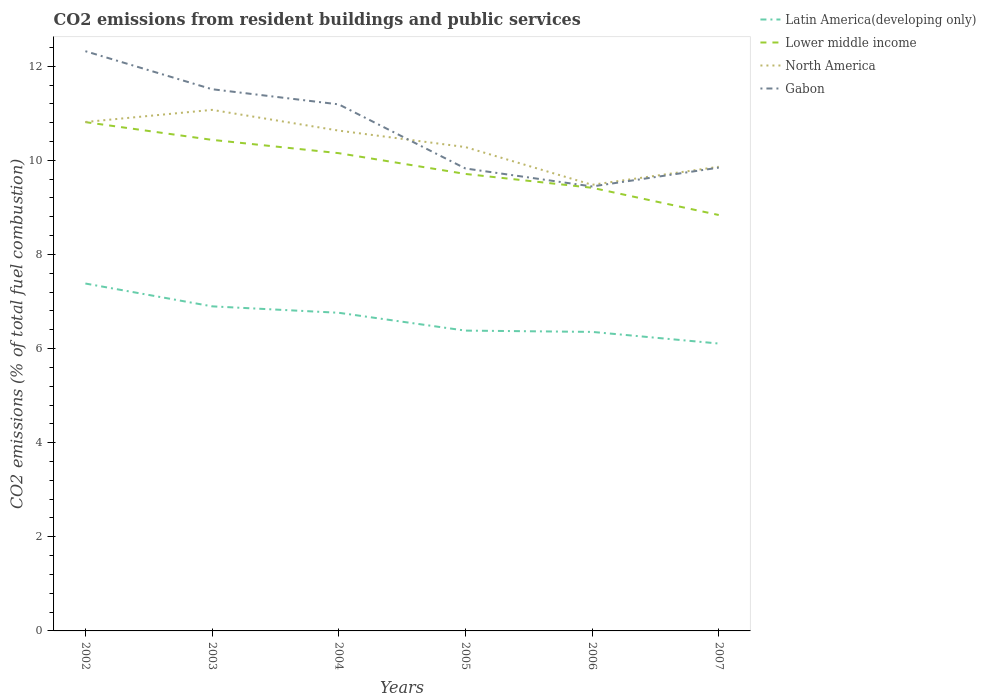How many different coloured lines are there?
Offer a very short reply. 4. Across all years, what is the maximum total CO2 emitted in Gabon?
Your response must be concise. 9.44. What is the total total CO2 emitted in North America in the graph?
Give a very brief answer. 1.21. What is the difference between the highest and the second highest total CO2 emitted in Latin America(developing only)?
Your answer should be compact. 1.28. How many lines are there?
Provide a short and direct response. 4. How many years are there in the graph?
Keep it short and to the point. 6. Does the graph contain grids?
Your answer should be compact. No. Where does the legend appear in the graph?
Ensure brevity in your answer.  Top right. What is the title of the graph?
Ensure brevity in your answer.  CO2 emissions from resident buildings and public services. What is the label or title of the Y-axis?
Provide a short and direct response. CO2 emissions (% of total fuel combustion). What is the CO2 emissions (% of total fuel combustion) in Latin America(developing only) in 2002?
Your answer should be compact. 7.38. What is the CO2 emissions (% of total fuel combustion) of Lower middle income in 2002?
Give a very brief answer. 10.81. What is the CO2 emissions (% of total fuel combustion) of North America in 2002?
Keep it short and to the point. 10.81. What is the CO2 emissions (% of total fuel combustion) of Gabon in 2002?
Your response must be concise. 12.32. What is the CO2 emissions (% of total fuel combustion) of Latin America(developing only) in 2003?
Offer a very short reply. 6.9. What is the CO2 emissions (% of total fuel combustion) in Lower middle income in 2003?
Provide a short and direct response. 10.43. What is the CO2 emissions (% of total fuel combustion) of North America in 2003?
Your answer should be compact. 11.07. What is the CO2 emissions (% of total fuel combustion) of Gabon in 2003?
Ensure brevity in your answer.  11.51. What is the CO2 emissions (% of total fuel combustion) in Latin America(developing only) in 2004?
Keep it short and to the point. 6.76. What is the CO2 emissions (% of total fuel combustion) of Lower middle income in 2004?
Your response must be concise. 10.15. What is the CO2 emissions (% of total fuel combustion) of North America in 2004?
Provide a short and direct response. 10.63. What is the CO2 emissions (% of total fuel combustion) in Gabon in 2004?
Provide a short and direct response. 11.19. What is the CO2 emissions (% of total fuel combustion) of Latin America(developing only) in 2005?
Your response must be concise. 6.38. What is the CO2 emissions (% of total fuel combustion) of Lower middle income in 2005?
Give a very brief answer. 9.71. What is the CO2 emissions (% of total fuel combustion) of North America in 2005?
Ensure brevity in your answer.  10.28. What is the CO2 emissions (% of total fuel combustion) in Gabon in 2005?
Your answer should be very brief. 9.83. What is the CO2 emissions (% of total fuel combustion) in Latin America(developing only) in 2006?
Ensure brevity in your answer.  6.35. What is the CO2 emissions (% of total fuel combustion) of Lower middle income in 2006?
Your answer should be compact. 9.42. What is the CO2 emissions (% of total fuel combustion) in North America in 2006?
Offer a very short reply. 9.48. What is the CO2 emissions (% of total fuel combustion) of Gabon in 2006?
Your answer should be compact. 9.44. What is the CO2 emissions (% of total fuel combustion) in Latin America(developing only) in 2007?
Provide a short and direct response. 6.11. What is the CO2 emissions (% of total fuel combustion) of Lower middle income in 2007?
Offer a very short reply. 8.84. What is the CO2 emissions (% of total fuel combustion) of North America in 2007?
Keep it short and to the point. 9.86. What is the CO2 emissions (% of total fuel combustion) in Gabon in 2007?
Keep it short and to the point. 9.84. Across all years, what is the maximum CO2 emissions (% of total fuel combustion) of Latin America(developing only)?
Provide a succinct answer. 7.38. Across all years, what is the maximum CO2 emissions (% of total fuel combustion) in Lower middle income?
Offer a terse response. 10.81. Across all years, what is the maximum CO2 emissions (% of total fuel combustion) of North America?
Keep it short and to the point. 11.07. Across all years, what is the maximum CO2 emissions (% of total fuel combustion) of Gabon?
Your response must be concise. 12.32. Across all years, what is the minimum CO2 emissions (% of total fuel combustion) of Latin America(developing only)?
Provide a short and direct response. 6.11. Across all years, what is the minimum CO2 emissions (% of total fuel combustion) of Lower middle income?
Provide a succinct answer. 8.84. Across all years, what is the minimum CO2 emissions (% of total fuel combustion) of North America?
Your answer should be very brief. 9.48. Across all years, what is the minimum CO2 emissions (% of total fuel combustion) in Gabon?
Offer a very short reply. 9.44. What is the total CO2 emissions (% of total fuel combustion) in Latin America(developing only) in the graph?
Offer a very short reply. 39.88. What is the total CO2 emissions (% of total fuel combustion) in Lower middle income in the graph?
Your answer should be compact. 59.36. What is the total CO2 emissions (% of total fuel combustion) in North America in the graph?
Keep it short and to the point. 62.14. What is the total CO2 emissions (% of total fuel combustion) of Gabon in the graph?
Offer a terse response. 64.13. What is the difference between the CO2 emissions (% of total fuel combustion) in Latin America(developing only) in 2002 and that in 2003?
Keep it short and to the point. 0.48. What is the difference between the CO2 emissions (% of total fuel combustion) in Lower middle income in 2002 and that in 2003?
Give a very brief answer. 0.38. What is the difference between the CO2 emissions (% of total fuel combustion) in North America in 2002 and that in 2003?
Ensure brevity in your answer.  -0.26. What is the difference between the CO2 emissions (% of total fuel combustion) in Gabon in 2002 and that in 2003?
Your answer should be very brief. 0.81. What is the difference between the CO2 emissions (% of total fuel combustion) of Latin America(developing only) in 2002 and that in 2004?
Make the answer very short. 0.62. What is the difference between the CO2 emissions (% of total fuel combustion) of Lower middle income in 2002 and that in 2004?
Your answer should be very brief. 0.66. What is the difference between the CO2 emissions (% of total fuel combustion) in North America in 2002 and that in 2004?
Make the answer very short. 0.18. What is the difference between the CO2 emissions (% of total fuel combustion) of Gabon in 2002 and that in 2004?
Your answer should be very brief. 1.13. What is the difference between the CO2 emissions (% of total fuel combustion) of Latin America(developing only) in 2002 and that in 2005?
Your answer should be compact. 1. What is the difference between the CO2 emissions (% of total fuel combustion) in Lower middle income in 2002 and that in 2005?
Ensure brevity in your answer.  1.1. What is the difference between the CO2 emissions (% of total fuel combustion) of North America in 2002 and that in 2005?
Offer a very short reply. 0.53. What is the difference between the CO2 emissions (% of total fuel combustion) in Gabon in 2002 and that in 2005?
Offer a very short reply. 2.49. What is the difference between the CO2 emissions (% of total fuel combustion) of Latin America(developing only) in 2002 and that in 2006?
Your answer should be very brief. 1.03. What is the difference between the CO2 emissions (% of total fuel combustion) of Lower middle income in 2002 and that in 2006?
Offer a very short reply. 1.4. What is the difference between the CO2 emissions (% of total fuel combustion) of North America in 2002 and that in 2006?
Ensure brevity in your answer.  1.33. What is the difference between the CO2 emissions (% of total fuel combustion) in Gabon in 2002 and that in 2006?
Offer a very short reply. 2.87. What is the difference between the CO2 emissions (% of total fuel combustion) in Latin America(developing only) in 2002 and that in 2007?
Offer a very short reply. 1.28. What is the difference between the CO2 emissions (% of total fuel combustion) in Lower middle income in 2002 and that in 2007?
Your answer should be very brief. 1.97. What is the difference between the CO2 emissions (% of total fuel combustion) in North America in 2002 and that in 2007?
Offer a terse response. 0.95. What is the difference between the CO2 emissions (% of total fuel combustion) in Gabon in 2002 and that in 2007?
Your answer should be compact. 2.47. What is the difference between the CO2 emissions (% of total fuel combustion) of Latin America(developing only) in 2003 and that in 2004?
Offer a terse response. 0.14. What is the difference between the CO2 emissions (% of total fuel combustion) of Lower middle income in 2003 and that in 2004?
Provide a short and direct response. 0.28. What is the difference between the CO2 emissions (% of total fuel combustion) in North America in 2003 and that in 2004?
Give a very brief answer. 0.44. What is the difference between the CO2 emissions (% of total fuel combustion) in Gabon in 2003 and that in 2004?
Make the answer very short. 0.32. What is the difference between the CO2 emissions (% of total fuel combustion) in Latin America(developing only) in 2003 and that in 2005?
Your response must be concise. 0.52. What is the difference between the CO2 emissions (% of total fuel combustion) in Lower middle income in 2003 and that in 2005?
Offer a terse response. 0.72. What is the difference between the CO2 emissions (% of total fuel combustion) in North America in 2003 and that in 2005?
Keep it short and to the point. 0.79. What is the difference between the CO2 emissions (% of total fuel combustion) in Gabon in 2003 and that in 2005?
Keep it short and to the point. 1.68. What is the difference between the CO2 emissions (% of total fuel combustion) of Latin America(developing only) in 2003 and that in 2006?
Provide a short and direct response. 0.54. What is the difference between the CO2 emissions (% of total fuel combustion) of Lower middle income in 2003 and that in 2006?
Keep it short and to the point. 1.02. What is the difference between the CO2 emissions (% of total fuel combustion) in North America in 2003 and that in 2006?
Ensure brevity in your answer.  1.59. What is the difference between the CO2 emissions (% of total fuel combustion) of Gabon in 2003 and that in 2006?
Ensure brevity in your answer.  2.07. What is the difference between the CO2 emissions (% of total fuel combustion) of Latin America(developing only) in 2003 and that in 2007?
Your answer should be compact. 0.79. What is the difference between the CO2 emissions (% of total fuel combustion) of Lower middle income in 2003 and that in 2007?
Keep it short and to the point. 1.6. What is the difference between the CO2 emissions (% of total fuel combustion) in North America in 2003 and that in 2007?
Keep it short and to the point. 1.21. What is the difference between the CO2 emissions (% of total fuel combustion) in Gabon in 2003 and that in 2007?
Your response must be concise. 1.67. What is the difference between the CO2 emissions (% of total fuel combustion) of Latin America(developing only) in 2004 and that in 2005?
Provide a succinct answer. 0.38. What is the difference between the CO2 emissions (% of total fuel combustion) of Lower middle income in 2004 and that in 2005?
Provide a succinct answer. 0.44. What is the difference between the CO2 emissions (% of total fuel combustion) of North America in 2004 and that in 2005?
Your response must be concise. 0.35. What is the difference between the CO2 emissions (% of total fuel combustion) of Gabon in 2004 and that in 2005?
Keep it short and to the point. 1.36. What is the difference between the CO2 emissions (% of total fuel combustion) in Latin America(developing only) in 2004 and that in 2006?
Your response must be concise. 0.41. What is the difference between the CO2 emissions (% of total fuel combustion) in Lower middle income in 2004 and that in 2006?
Your response must be concise. 0.74. What is the difference between the CO2 emissions (% of total fuel combustion) of North America in 2004 and that in 2006?
Give a very brief answer. 1.15. What is the difference between the CO2 emissions (% of total fuel combustion) of Gabon in 2004 and that in 2006?
Provide a succinct answer. 1.74. What is the difference between the CO2 emissions (% of total fuel combustion) of Latin America(developing only) in 2004 and that in 2007?
Provide a succinct answer. 0.65. What is the difference between the CO2 emissions (% of total fuel combustion) in Lower middle income in 2004 and that in 2007?
Make the answer very short. 1.31. What is the difference between the CO2 emissions (% of total fuel combustion) in North America in 2004 and that in 2007?
Your answer should be very brief. 0.77. What is the difference between the CO2 emissions (% of total fuel combustion) in Gabon in 2004 and that in 2007?
Your answer should be compact. 1.34. What is the difference between the CO2 emissions (% of total fuel combustion) of Latin America(developing only) in 2005 and that in 2006?
Make the answer very short. 0.03. What is the difference between the CO2 emissions (% of total fuel combustion) in Lower middle income in 2005 and that in 2006?
Keep it short and to the point. 0.29. What is the difference between the CO2 emissions (% of total fuel combustion) of North America in 2005 and that in 2006?
Your answer should be compact. 0.8. What is the difference between the CO2 emissions (% of total fuel combustion) in Gabon in 2005 and that in 2006?
Offer a very short reply. 0.38. What is the difference between the CO2 emissions (% of total fuel combustion) in Latin America(developing only) in 2005 and that in 2007?
Offer a terse response. 0.27. What is the difference between the CO2 emissions (% of total fuel combustion) of Lower middle income in 2005 and that in 2007?
Keep it short and to the point. 0.87. What is the difference between the CO2 emissions (% of total fuel combustion) in North America in 2005 and that in 2007?
Your answer should be compact. 0.42. What is the difference between the CO2 emissions (% of total fuel combustion) in Gabon in 2005 and that in 2007?
Provide a succinct answer. -0.02. What is the difference between the CO2 emissions (% of total fuel combustion) in Latin America(developing only) in 2006 and that in 2007?
Offer a very short reply. 0.25. What is the difference between the CO2 emissions (% of total fuel combustion) of Lower middle income in 2006 and that in 2007?
Ensure brevity in your answer.  0.58. What is the difference between the CO2 emissions (% of total fuel combustion) of North America in 2006 and that in 2007?
Give a very brief answer. -0.38. What is the difference between the CO2 emissions (% of total fuel combustion) in Gabon in 2006 and that in 2007?
Your response must be concise. -0.4. What is the difference between the CO2 emissions (% of total fuel combustion) of Latin America(developing only) in 2002 and the CO2 emissions (% of total fuel combustion) of Lower middle income in 2003?
Make the answer very short. -3.05. What is the difference between the CO2 emissions (% of total fuel combustion) in Latin America(developing only) in 2002 and the CO2 emissions (% of total fuel combustion) in North America in 2003?
Ensure brevity in your answer.  -3.69. What is the difference between the CO2 emissions (% of total fuel combustion) in Latin America(developing only) in 2002 and the CO2 emissions (% of total fuel combustion) in Gabon in 2003?
Your answer should be very brief. -4.13. What is the difference between the CO2 emissions (% of total fuel combustion) in Lower middle income in 2002 and the CO2 emissions (% of total fuel combustion) in North America in 2003?
Make the answer very short. -0.26. What is the difference between the CO2 emissions (% of total fuel combustion) in Lower middle income in 2002 and the CO2 emissions (% of total fuel combustion) in Gabon in 2003?
Give a very brief answer. -0.7. What is the difference between the CO2 emissions (% of total fuel combustion) of North America in 2002 and the CO2 emissions (% of total fuel combustion) of Gabon in 2003?
Your answer should be compact. -0.7. What is the difference between the CO2 emissions (% of total fuel combustion) of Latin America(developing only) in 2002 and the CO2 emissions (% of total fuel combustion) of Lower middle income in 2004?
Ensure brevity in your answer.  -2.77. What is the difference between the CO2 emissions (% of total fuel combustion) of Latin America(developing only) in 2002 and the CO2 emissions (% of total fuel combustion) of North America in 2004?
Ensure brevity in your answer.  -3.25. What is the difference between the CO2 emissions (% of total fuel combustion) of Latin America(developing only) in 2002 and the CO2 emissions (% of total fuel combustion) of Gabon in 2004?
Provide a succinct answer. -3.81. What is the difference between the CO2 emissions (% of total fuel combustion) in Lower middle income in 2002 and the CO2 emissions (% of total fuel combustion) in North America in 2004?
Ensure brevity in your answer.  0.18. What is the difference between the CO2 emissions (% of total fuel combustion) in Lower middle income in 2002 and the CO2 emissions (% of total fuel combustion) in Gabon in 2004?
Ensure brevity in your answer.  -0.38. What is the difference between the CO2 emissions (% of total fuel combustion) of North America in 2002 and the CO2 emissions (% of total fuel combustion) of Gabon in 2004?
Provide a succinct answer. -0.37. What is the difference between the CO2 emissions (% of total fuel combustion) of Latin America(developing only) in 2002 and the CO2 emissions (% of total fuel combustion) of Lower middle income in 2005?
Your answer should be very brief. -2.33. What is the difference between the CO2 emissions (% of total fuel combustion) of Latin America(developing only) in 2002 and the CO2 emissions (% of total fuel combustion) of North America in 2005?
Keep it short and to the point. -2.9. What is the difference between the CO2 emissions (% of total fuel combustion) in Latin America(developing only) in 2002 and the CO2 emissions (% of total fuel combustion) in Gabon in 2005?
Give a very brief answer. -2.44. What is the difference between the CO2 emissions (% of total fuel combustion) of Lower middle income in 2002 and the CO2 emissions (% of total fuel combustion) of North America in 2005?
Your answer should be very brief. 0.53. What is the difference between the CO2 emissions (% of total fuel combustion) in Lower middle income in 2002 and the CO2 emissions (% of total fuel combustion) in Gabon in 2005?
Give a very brief answer. 0.99. What is the difference between the CO2 emissions (% of total fuel combustion) in Latin America(developing only) in 2002 and the CO2 emissions (% of total fuel combustion) in Lower middle income in 2006?
Provide a short and direct response. -2.03. What is the difference between the CO2 emissions (% of total fuel combustion) of Latin America(developing only) in 2002 and the CO2 emissions (% of total fuel combustion) of North America in 2006?
Ensure brevity in your answer.  -2.1. What is the difference between the CO2 emissions (% of total fuel combustion) in Latin America(developing only) in 2002 and the CO2 emissions (% of total fuel combustion) in Gabon in 2006?
Keep it short and to the point. -2.06. What is the difference between the CO2 emissions (% of total fuel combustion) of Lower middle income in 2002 and the CO2 emissions (% of total fuel combustion) of North America in 2006?
Your answer should be compact. 1.33. What is the difference between the CO2 emissions (% of total fuel combustion) of Lower middle income in 2002 and the CO2 emissions (% of total fuel combustion) of Gabon in 2006?
Offer a terse response. 1.37. What is the difference between the CO2 emissions (% of total fuel combustion) in North America in 2002 and the CO2 emissions (% of total fuel combustion) in Gabon in 2006?
Your answer should be compact. 1.37. What is the difference between the CO2 emissions (% of total fuel combustion) in Latin America(developing only) in 2002 and the CO2 emissions (% of total fuel combustion) in Lower middle income in 2007?
Your answer should be very brief. -1.46. What is the difference between the CO2 emissions (% of total fuel combustion) of Latin America(developing only) in 2002 and the CO2 emissions (% of total fuel combustion) of North America in 2007?
Your answer should be very brief. -2.48. What is the difference between the CO2 emissions (% of total fuel combustion) in Latin America(developing only) in 2002 and the CO2 emissions (% of total fuel combustion) in Gabon in 2007?
Keep it short and to the point. -2.46. What is the difference between the CO2 emissions (% of total fuel combustion) of Lower middle income in 2002 and the CO2 emissions (% of total fuel combustion) of North America in 2007?
Make the answer very short. 0.95. What is the difference between the CO2 emissions (% of total fuel combustion) in Lower middle income in 2002 and the CO2 emissions (% of total fuel combustion) in Gabon in 2007?
Your response must be concise. 0.97. What is the difference between the CO2 emissions (% of total fuel combustion) of North America in 2002 and the CO2 emissions (% of total fuel combustion) of Gabon in 2007?
Offer a very short reply. 0.97. What is the difference between the CO2 emissions (% of total fuel combustion) of Latin America(developing only) in 2003 and the CO2 emissions (% of total fuel combustion) of Lower middle income in 2004?
Your answer should be very brief. -3.25. What is the difference between the CO2 emissions (% of total fuel combustion) in Latin America(developing only) in 2003 and the CO2 emissions (% of total fuel combustion) in North America in 2004?
Your answer should be very brief. -3.73. What is the difference between the CO2 emissions (% of total fuel combustion) of Latin America(developing only) in 2003 and the CO2 emissions (% of total fuel combustion) of Gabon in 2004?
Provide a succinct answer. -4.29. What is the difference between the CO2 emissions (% of total fuel combustion) in Lower middle income in 2003 and the CO2 emissions (% of total fuel combustion) in North America in 2004?
Give a very brief answer. -0.2. What is the difference between the CO2 emissions (% of total fuel combustion) in Lower middle income in 2003 and the CO2 emissions (% of total fuel combustion) in Gabon in 2004?
Your response must be concise. -0.75. What is the difference between the CO2 emissions (% of total fuel combustion) in North America in 2003 and the CO2 emissions (% of total fuel combustion) in Gabon in 2004?
Give a very brief answer. -0.12. What is the difference between the CO2 emissions (% of total fuel combustion) in Latin America(developing only) in 2003 and the CO2 emissions (% of total fuel combustion) in Lower middle income in 2005?
Make the answer very short. -2.81. What is the difference between the CO2 emissions (% of total fuel combustion) in Latin America(developing only) in 2003 and the CO2 emissions (% of total fuel combustion) in North America in 2005?
Your response must be concise. -3.38. What is the difference between the CO2 emissions (% of total fuel combustion) of Latin America(developing only) in 2003 and the CO2 emissions (% of total fuel combustion) of Gabon in 2005?
Provide a short and direct response. -2.93. What is the difference between the CO2 emissions (% of total fuel combustion) in Lower middle income in 2003 and the CO2 emissions (% of total fuel combustion) in North America in 2005?
Your answer should be compact. 0.15. What is the difference between the CO2 emissions (% of total fuel combustion) in Lower middle income in 2003 and the CO2 emissions (% of total fuel combustion) in Gabon in 2005?
Your answer should be compact. 0.61. What is the difference between the CO2 emissions (% of total fuel combustion) of North America in 2003 and the CO2 emissions (% of total fuel combustion) of Gabon in 2005?
Your response must be concise. 1.25. What is the difference between the CO2 emissions (% of total fuel combustion) of Latin America(developing only) in 2003 and the CO2 emissions (% of total fuel combustion) of Lower middle income in 2006?
Offer a terse response. -2.52. What is the difference between the CO2 emissions (% of total fuel combustion) in Latin America(developing only) in 2003 and the CO2 emissions (% of total fuel combustion) in North America in 2006?
Make the answer very short. -2.58. What is the difference between the CO2 emissions (% of total fuel combustion) in Latin America(developing only) in 2003 and the CO2 emissions (% of total fuel combustion) in Gabon in 2006?
Offer a very short reply. -2.55. What is the difference between the CO2 emissions (% of total fuel combustion) in Lower middle income in 2003 and the CO2 emissions (% of total fuel combustion) in North America in 2006?
Ensure brevity in your answer.  0.95. What is the difference between the CO2 emissions (% of total fuel combustion) in Lower middle income in 2003 and the CO2 emissions (% of total fuel combustion) in Gabon in 2006?
Your answer should be very brief. 0.99. What is the difference between the CO2 emissions (% of total fuel combustion) of North America in 2003 and the CO2 emissions (% of total fuel combustion) of Gabon in 2006?
Offer a very short reply. 1.63. What is the difference between the CO2 emissions (% of total fuel combustion) in Latin America(developing only) in 2003 and the CO2 emissions (% of total fuel combustion) in Lower middle income in 2007?
Offer a terse response. -1.94. What is the difference between the CO2 emissions (% of total fuel combustion) in Latin America(developing only) in 2003 and the CO2 emissions (% of total fuel combustion) in North America in 2007?
Provide a succinct answer. -2.97. What is the difference between the CO2 emissions (% of total fuel combustion) in Latin America(developing only) in 2003 and the CO2 emissions (% of total fuel combustion) in Gabon in 2007?
Keep it short and to the point. -2.95. What is the difference between the CO2 emissions (% of total fuel combustion) of Lower middle income in 2003 and the CO2 emissions (% of total fuel combustion) of North America in 2007?
Make the answer very short. 0.57. What is the difference between the CO2 emissions (% of total fuel combustion) of Lower middle income in 2003 and the CO2 emissions (% of total fuel combustion) of Gabon in 2007?
Keep it short and to the point. 0.59. What is the difference between the CO2 emissions (% of total fuel combustion) in North America in 2003 and the CO2 emissions (% of total fuel combustion) in Gabon in 2007?
Offer a very short reply. 1.23. What is the difference between the CO2 emissions (% of total fuel combustion) in Latin America(developing only) in 2004 and the CO2 emissions (% of total fuel combustion) in Lower middle income in 2005?
Your response must be concise. -2.95. What is the difference between the CO2 emissions (% of total fuel combustion) in Latin America(developing only) in 2004 and the CO2 emissions (% of total fuel combustion) in North America in 2005?
Give a very brief answer. -3.52. What is the difference between the CO2 emissions (% of total fuel combustion) in Latin America(developing only) in 2004 and the CO2 emissions (% of total fuel combustion) in Gabon in 2005?
Your answer should be very brief. -3.07. What is the difference between the CO2 emissions (% of total fuel combustion) in Lower middle income in 2004 and the CO2 emissions (% of total fuel combustion) in North America in 2005?
Provide a short and direct response. -0.13. What is the difference between the CO2 emissions (% of total fuel combustion) in Lower middle income in 2004 and the CO2 emissions (% of total fuel combustion) in Gabon in 2005?
Offer a terse response. 0.33. What is the difference between the CO2 emissions (% of total fuel combustion) of North America in 2004 and the CO2 emissions (% of total fuel combustion) of Gabon in 2005?
Your answer should be compact. 0.8. What is the difference between the CO2 emissions (% of total fuel combustion) in Latin America(developing only) in 2004 and the CO2 emissions (% of total fuel combustion) in Lower middle income in 2006?
Ensure brevity in your answer.  -2.66. What is the difference between the CO2 emissions (% of total fuel combustion) of Latin America(developing only) in 2004 and the CO2 emissions (% of total fuel combustion) of North America in 2006?
Give a very brief answer. -2.72. What is the difference between the CO2 emissions (% of total fuel combustion) of Latin America(developing only) in 2004 and the CO2 emissions (% of total fuel combustion) of Gabon in 2006?
Give a very brief answer. -2.68. What is the difference between the CO2 emissions (% of total fuel combustion) in Lower middle income in 2004 and the CO2 emissions (% of total fuel combustion) in North America in 2006?
Provide a succinct answer. 0.67. What is the difference between the CO2 emissions (% of total fuel combustion) of Lower middle income in 2004 and the CO2 emissions (% of total fuel combustion) of Gabon in 2006?
Ensure brevity in your answer.  0.71. What is the difference between the CO2 emissions (% of total fuel combustion) in North America in 2004 and the CO2 emissions (% of total fuel combustion) in Gabon in 2006?
Provide a succinct answer. 1.19. What is the difference between the CO2 emissions (% of total fuel combustion) in Latin America(developing only) in 2004 and the CO2 emissions (% of total fuel combustion) in Lower middle income in 2007?
Ensure brevity in your answer.  -2.08. What is the difference between the CO2 emissions (% of total fuel combustion) in Latin America(developing only) in 2004 and the CO2 emissions (% of total fuel combustion) in North America in 2007?
Give a very brief answer. -3.1. What is the difference between the CO2 emissions (% of total fuel combustion) of Latin America(developing only) in 2004 and the CO2 emissions (% of total fuel combustion) of Gabon in 2007?
Your answer should be very brief. -3.08. What is the difference between the CO2 emissions (% of total fuel combustion) in Lower middle income in 2004 and the CO2 emissions (% of total fuel combustion) in North America in 2007?
Provide a succinct answer. 0.29. What is the difference between the CO2 emissions (% of total fuel combustion) in Lower middle income in 2004 and the CO2 emissions (% of total fuel combustion) in Gabon in 2007?
Offer a very short reply. 0.31. What is the difference between the CO2 emissions (% of total fuel combustion) of North America in 2004 and the CO2 emissions (% of total fuel combustion) of Gabon in 2007?
Ensure brevity in your answer.  0.79. What is the difference between the CO2 emissions (% of total fuel combustion) of Latin America(developing only) in 2005 and the CO2 emissions (% of total fuel combustion) of Lower middle income in 2006?
Provide a succinct answer. -3.03. What is the difference between the CO2 emissions (% of total fuel combustion) of Latin America(developing only) in 2005 and the CO2 emissions (% of total fuel combustion) of North America in 2006?
Give a very brief answer. -3.1. What is the difference between the CO2 emissions (% of total fuel combustion) of Latin America(developing only) in 2005 and the CO2 emissions (% of total fuel combustion) of Gabon in 2006?
Provide a succinct answer. -3.06. What is the difference between the CO2 emissions (% of total fuel combustion) in Lower middle income in 2005 and the CO2 emissions (% of total fuel combustion) in North America in 2006?
Your answer should be very brief. 0.23. What is the difference between the CO2 emissions (% of total fuel combustion) in Lower middle income in 2005 and the CO2 emissions (% of total fuel combustion) in Gabon in 2006?
Your response must be concise. 0.27. What is the difference between the CO2 emissions (% of total fuel combustion) in North America in 2005 and the CO2 emissions (% of total fuel combustion) in Gabon in 2006?
Make the answer very short. 0.84. What is the difference between the CO2 emissions (% of total fuel combustion) in Latin America(developing only) in 2005 and the CO2 emissions (% of total fuel combustion) in Lower middle income in 2007?
Provide a succinct answer. -2.46. What is the difference between the CO2 emissions (% of total fuel combustion) in Latin America(developing only) in 2005 and the CO2 emissions (% of total fuel combustion) in North America in 2007?
Provide a short and direct response. -3.48. What is the difference between the CO2 emissions (% of total fuel combustion) in Latin America(developing only) in 2005 and the CO2 emissions (% of total fuel combustion) in Gabon in 2007?
Make the answer very short. -3.46. What is the difference between the CO2 emissions (% of total fuel combustion) in Lower middle income in 2005 and the CO2 emissions (% of total fuel combustion) in North America in 2007?
Your answer should be very brief. -0.15. What is the difference between the CO2 emissions (% of total fuel combustion) of Lower middle income in 2005 and the CO2 emissions (% of total fuel combustion) of Gabon in 2007?
Your answer should be compact. -0.13. What is the difference between the CO2 emissions (% of total fuel combustion) in North America in 2005 and the CO2 emissions (% of total fuel combustion) in Gabon in 2007?
Your answer should be compact. 0.44. What is the difference between the CO2 emissions (% of total fuel combustion) of Latin America(developing only) in 2006 and the CO2 emissions (% of total fuel combustion) of Lower middle income in 2007?
Offer a very short reply. -2.48. What is the difference between the CO2 emissions (% of total fuel combustion) in Latin America(developing only) in 2006 and the CO2 emissions (% of total fuel combustion) in North America in 2007?
Provide a short and direct response. -3.51. What is the difference between the CO2 emissions (% of total fuel combustion) in Latin America(developing only) in 2006 and the CO2 emissions (% of total fuel combustion) in Gabon in 2007?
Provide a short and direct response. -3.49. What is the difference between the CO2 emissions (% of total fuel combustion) of Lower middle income in 2006 and the CO2 emissions (% of total fuel combustion) of North America in 2007?
Provide a short and direct response. -0.45. What is the difference between the CO2 emissions (% of total fuel combustion) in Lower middle income in 2006 and the CO2 emissions (% of total fuel combustion) in Gabon in 2007?
Your response must be concise. -0.43. What is the difference between the CO2 emissions (% of total fuel combustion) of North America in 2006 and the CO2 emissions (% of total fuel combustion) of Gabon in 2007?
Keep it short and to the point. -0.36. What is the average CO2 emissions (% of total fuel combustion) in Latin America(developing only) per year?
Provide a succinct answer. 6.65. What is the average CO2 emissions (% of total fuel combustion) of Lower middle income per year?
Keep it short and to the point. 9.89. What is the average CO2 emissions (% of total fuel combustion) of North America per year?
Your response must be concise. 10.36. What is the average CO2 emissions (% of total fuel combustion) of Gabon per year?
Your response must be concise. 10.69. In the year 2002, what is the difference between the CO2 emissions (% of total fuel combustion) in Latin America(developing only) and CO2 emissions (% of total fuel combustion) in Lower middle income?
Offer a terse response. -3.43. In the year 2002, what is the difference between the CO2 emissions (% of total fuel combustion) in Latin America(developing only) and CO2 emissions (% of total fuel combustion) in North America?
Ensure brevity in your answer.  -3.43. In the year 2002, what is the difference between the CO2 emissions (% of total fuel combustion) in Latin America(developing only) and CO2 emissions (% of total fuel combustion) in Gabon?
Offer a terse response. -4.94. In the year 2002, what is the difference between the CO2 emissions (% of total fuel combustion) in Lower middle income and CO2 emissions (% of total fuel combustion) in North America?
Your answer should be compact. -0. In the year 2002, what is the difference between the CO2 emissions (% of total fuel combustion) in Lower middle income and CO2 emissions (% of total fuel combustion) in Gabon?
Give a very brief answer. -1.51. In the year 2002, what is the difference between the CO2 emissions (% of total fuel combustion) of North America and CO2 emissions (% of total fuel combustion) of Gabon?
Give a very brief answer. -1.5. In the year 2003, what is the difference between the CO2 emissions (% of total fuel combustion) of Latin America(developing only) and CO2 emissions (% of total fuel combustion) of Lower middle income?
Give a very brief answer. -3.54. In the year 2003, what is the difference between the CO2 emissions (% of total fuel combustion) in Latin America(developing only) and CO2 emissions (% of total fuel combustion) in North America?
Provide a short and direct response. -4.17. In the year 2003, what is the difference between the CO2 emissions (% of total fuel combustion) in Latin America(developing only) and CO2 emissions (% of total fuel combustion) in Gabon?
Provide a short and direct response. -4.61. In the year 2003, what is the difference between the CO2 emissions (% of total fuel combustion) in Lower middle income and CO2 emissions (% of total fuel combustion) in North America?
Your answer should be compact. -0.64. In the year 2003, what is the difference between the CO2 emissions (% of total fuel combustion) in Lower middle income and CO2 emissions (% of total fuel combustion) in Gabon?
Offer a terse response. -1.08. In the year 2003, what is the difference between the CO2 emissions (% of total fuel combustion) in North America and CO2 emissions (% of total fuel combustion) in Gabon?
Your answer should be very brief. -0.44. In the year 2004, what is the difference between the CO2 emissions (% of total fuel combustion) in Latin America(developing only) and CO2 emissions (% of total fuel combustion) in Lower middle income?
Your response must be concise. -3.39. In the year 2004, what is the difference between the CO2 emissions (% of total fuel combustion) in Latin America(developing only) and CO2 emissions (% of total fuel combustion) in North America?
Your answer should be very brief. -3.87. In the year 2004, what is the difference between the CO2 emissions (% of total fuel combustion) of Latin America(developing only) and CO2 emissions (% of total fuel combustion) of Gabon?
Offer a terse response. -4.43. In the year 2004, what is the difference between the CO2 emissions (% of total fuel combustion) of Lower middle income and CO2 emissions (% of total fuel combustion) of North America?
Provide a succinct answer. -0.48. In the year 2004, what is the difference between the CO2 emissions (% of total fuel combustion) in Lower middle income and CO2 emissions (% of total fuel combustion) in Gabon?
Provide a short and direct response. -1.04. In the year 2004, what is the difference between the CO2 emissions (% of total fuel combustion) in North America and CO2 emissions (% of total fuel combustion) in Gabon?
Your response must be concise. -0.56. In the year 2005, what is the difference between the CO2 emissions (% of total fuel combustion) in Latin America(developing only) and CO2 emissions (% of total fuel combustion) in Lower middle income?
Provide a succinct answer. -3.33. In the year 2005, what is the difference between the CO2 emissions (% of total fuel combustion) in Latin America(developing only) and CO2 emissions (% of total fuel combustion) in North America?
Provide a short and direct response. -3.9. In the year 2005, what is the difference between the CO2 emissions (% of total fuel combustion) in Latin America(developing only) and CO2 emissions (% of total fuel combustion) in Gabon?
Your answer should be very brief. -3.45. In the year 2005, what is the difference between the CO2 emissions (% of total fuel combustion) in Lower middle income and CO2 emissions (% of total fuel combustion) in North America?
Provide a short and direct response. -0.57. In the year 2005, what is the difference between the CO2 emissions (% of total fuel combustion) of Lower middle income and CO2 emissions (% of total fuel combustion) of Gabon?
Provide a succinct answer. -0.12. In the year 2005, what is the difference between the CO2 emissions (% of total fuel combustion) of North America and CO2 emissions (% of total fuel combustion) of Gabon?
Provide a succinct answer. 0.46. In the year 2006, what is the difference between the CO2 emissions (% of total fuel combustion) in Latin America(developing only) and CO2 emissions (% of total fuel combustion) in Lower middle income?
Your answer should be compact. -3.06. In the year 2006, what is the difference between the CO2 emissions (% of total fuel combustion) in Latin America(developing only) and CO2 emissions (% of total fuel combustion) in North America?
Offer a very short reply. -3.13. In the year 2006, what is the difference between the CO2 emissions (% of total fuel combustion) in Latin America(developing only) and CO2 emissions (% of total fuel combustion) in Gabon?
Your answer should be very brief. -3.09. In the year 2006, what is the difference between the CO2 emissions (% of total fuel combustion) of Lower middle income and CO2 emissions (% of total fuel combustion) of North America?
Provide a short and direct response. -0.06. In the year 2006, what is the difference between the CO2 emissions (% of total fuel combustion) in Lower middle income and CO2 emissions (% of total fuel combustion) in Gabon?
Offer a terse response. -0.03. In the year 2006, what is the difference between the CO2 emissions (% of total fuel combustion) of North America and CO2 emissions (% of total fuel combustion) of Gabon?
Your answer should be very brief. 0.04. In the year 2007, what is the difference between the CO2 emissions (% of total fuel combustion) of Latin America(developing only) and CO2 emissions (% of total fuel combustion) of Lower middle income?
Make the answer very short. -2.73. In the year 2007, what is the difference between the CO2 emissions (% of total fuel combustion) in Latin America(developing only) and CO2 emissions (% of total fuel combustion) in North America?
Your answer should be very brief. -3.76. In the year 2007, what is the difference between the CO2 emissions (% of total fuel combustion) of Latin America(developing only) and CO2 emissions (% of total fuel combustion) of Gabon?
Your response must be concise. -3.74. In the year 2007, what is the difference between the CO2 emissions (% of total fuel combustion) of Lower middle income and CO2 emissions (% of total fuel combustion) of North America?
Provide a succinct answer. -1.02. In the year 2007, what is the difference between the CO2 emissions (% of total fuel combustion) of Lower middle income and CO2 emissions (% of total fuel combustion) of Gabon?
Offer a very short reply. -1.01. In the year 2007, what is the difference between the CO2 emissions (% of total fuel combustion) of North America and CO2 emissions (% of total fuel combustion) of Gabon?
Offer a terse response. 0.02. What is the ratio of the CO2 emissions (% of total fuel combustion) in Latin America(developing only) in 2002 to that in 2003?
Your response must be concise. 1.07. What is the ratio of the CO2 emissions (% of total fuel combustion) in Lower middle income in 2002 to that in 2003?
Provide a short and direct response. 1.04. What is the ratio of the CO2 emissions (% of total fuel combustion) in North America in 2002 to that in 2003?
Your response must be concise. 0.98. What is the ratio of the CO2 emissions (% of total fuel combustion) of Gabon in 2002 to that in 2003?
Keep it short and to the point. 1.07. What is the ratio of the CO2 emissions (% of total fuel combustion) in Latin America(developing only) in 2002 to that in 2004?
Provide a succinct answer. 1.09. What is the ratio of the CO2 emissions (% of total fuel combustion) of Lower middle income in 2002 to that in 2004?
Give a very brief answer. 1.06. What is the ratio of the CO2 emissions (% of total fuel combustion) of North America in 2002 to that in 2004?
Ensure brevity in your answer.  1.02. What is the ratio of the CO2 emissions (% of total fuel combustion) of Gabon in 2002 to that in 2004?
Your answer should be compact. 1.1. What is the ratio of the CO2 emissions (% of total fuel combustion) of Latin America(developing only) in 2002 to that in 2005?
Provide a short and direct response. 1.16. What is the ratio of the CO2 emissions (% of total fuel combustion) in Lower middle income in 2002 to that in 2005?
Provide a short and direct response. 1.11. What is the ratio of the CO2 emissions (% of total fuel combustion) in North America in 2002 to that in 2005?
Your answer should be very brief. 1.05. What is the ratio of the CO2 emissions (% of total fuel combustion) of Gabon in 2002 to that in 2005?
Keep it short and to the point. 1.25. What is the ratio of the CO2 emissions (% of total fuel combustion) in Latin America(developing only) in 2002 to that in 2006?
Ensure brevity in your answer.  1.16. What is the ratio of the CO2 emissions (% of total fuel combustion) in Lower middle income in 2002 to that in 2006?
Provide a succinct answer. 1.15. What is the ratio of the CO2 emissions (% of total fuel combustion) in North America in 2002 to that in 2006?
Your answer should be very brief. 1.14. What is the ratio of the CO2 emissions (% of total fuel combustion) of Gabon in 2002 to that in 2006?
Offer a very short reply. 1.3. What is the ratio of the CO2 emissions (% of total fuel combustion) of Latin America(developing only) in 2002 to that in 2007?
Keep it short and to the point. 1.21. What is the ratio of the CO2 emissions (% of total fuel combustion) in Lower middle income in 2002 to that in 2007?
Give a very brief answer. 1.22. What is the ratio of the CO2 emissions (% of total fuel combustion) of North America in 2002 to that in 2007?
Make the answer very short. 1.1. What is the ratio of the CO2 emissions (% of total fuel combustion) in Gabon in 2002 to that in 2007?
Your answer should be very brief. 1.25. What is the ratio of the CO2 emissions (% of total fuel combustion) in Latin America(developing only) in 2003 to that in 2004?
Offer a very short reply. 1.02. What is the ratio of the CO2 emissions (% of total fuel combustion) in Lower middle income in 2003 to that in 2004?
Your response must be concise. 1.03. What is the ratio of the CO2 emissions (% of total fuel combustion) of North America in 2003 to that in 2004?
Keep it short and to the point. 1.04. What is the ratio of the CO2 emissions (% of total fuel combustion) of Gabon in 2003 to that in 2004?
Your answer should be very brief. 1.03. What is the ratio of the CO2 emissions (% of total fuel combustion) in Latin America(developing only) in 2003 to that in 2005?
Your response must be concise. 1.08. What is the ratio of the CO2 emissions (% of total fuel combustion) of Lower middle income in 2003 to that in 2005?
Make the answer very short. 1.07. What is the ratio of the CO2 emissions (% of total fuel combustion) of Gabon in 2003 to that in 2005?
Offer a terse response. 1.17. What is the ratio of the CO2 emissions (% of total fuel combustion) of Latin America(developing only) in 2003 to that in 2006?
Your answer should be compact. 1.09. What is the ratio of the CO2 emissions (% of total fuel combustion) of Lower middle income in 2003 to that in 2006?
Make the answer very short. 1.11. What is the ratio of the CO2 emissions (% of total fuel combustion) in North America in 2003 to that in 2006?
Give a very brief answer. 1.17. What is the ratio of the CO2 emissions (% of total fuel combustion) in Gabon in 2003 to that in 2006?
Ensure brevity in your answer.  1.22. What is the ratio of the CO2 emissions (% of total fuel combustion) of Latin America(developing only) in 2003 to that in 2007?
Your response must be concise. 1.13. What is the ratio of the CO2 emissions (% of total fuel combustion) of Lower middle income in 2003 to that in 2007?
Your answer should be very brief. 1.18. What is the ratio of the CO2 emissions (% of total fuel combustion) in North America in 2003 to that in 2007?
Provide a succinct answer. 1.12. What is the ratio of the CO2 emissions (% of total fuel combustion) of Gabon in 2003 to that in 2007?
Your answer should be compact. 1.17. What is the ratio of the CO2 emissions (% of total fuel combustion) of Latin America(developing only) in 2004 to that in 2005?
Offer a terse response. 1.06. What is the ratio of the CO2 emissions (% of total fuel combustion) in Lower middle income in 2004 to that in 2005?
Provide a succinct answer. 1.05. What is the ratio of the CO2 emissions (% of total fuel combustion) in North America in 2004 to that in 2005?
Provide a succinct answer. 1.03. What is the ratio of the CO2 emissions (% of total fuel combustion) in Gabon in 2004 to that in 2005?
Ensure brevity in your answer.  1.14. What is the ratio of the CO2 emissions (% of total fuel combustion) in Latin America(developing only) in 2004 to that in 2006?
Your response must be concise. 1.06. What is the ratio of the CO2 emissions (% of total fuel combustion) in Lower middle income in 2004 to that in 2006?
Keep it short and to the point. 1.08. What is the ratio of the CO2 emissions (% of total fuel combustion) of North America in 2004 to that in 2006?
Give a very brief answer. 1.12. What is the ratio of the CO2 emissions (% of total fuel combustion) of Gabon in 2004 to that in 2006?
Provide a succinct answer. 1.18. What is the ratio of the CO2 emissions (% of total fuel combustion) of Latin America(developing only) in 2004 to that in 2007?
Provide a short and direct response. 1.11. What is the ratio of the CO2 emissions (% of total fuel combustion) of Lower middle income in 2004 to that in 2007?
Ensure brevity in your answer.  1.15. What is the ratio of the CO2 emissions (% of total fuel combustion) of North America in 2004 to that in 2007?
Keep it short and to the point. 1.08. What is the ratio of the CO2 emissions (% of total fuel combustion) of Gabon in 2004 to that in 2007?
Offer a terse response. 1.14. What is the ratio of the CO2 emissions (% of total fuel combustion) of Lower middle income in 2005 to that in 2006?
Keep it short and to the point. 1.03. What is the ratio of the CO2 emissions (% of total fuel combustion) of North America in 2005 to that in 2006?
Your response must be concise. 1.08. What is the ratio of the CO2 emissions (% of total fuel combustion) in Gabon in 2005 to that in 2006?
Make the answer very short. 1.04. What is the ratio of the CO2 emissions (% of total fuel combustion) of Latin America(developing only) in 2005 to that in 2007?
Keep it short and to the point. 1.04. What is the ratio of the CO2 emissions (% of total fuel combustion) in Lower middle income in 2005 to that in 2007?
Make the answer very short. 1.1. What is the ratio of the CO2 emissions (% of total fuel combustion) of North America in 2005 to that in 2007?
Keep it short and to the point. 1.04. What is the ratio of the CO2 emissions (% of total fuel combustion) in Latin America(developing only) in 2006 to that in 2007?
Keep it short and to the point. 1.04. What is the ratio of the CO2 emissions (% of total fuel combustion) in Lower middle income in 2006 to that in 2007?
Your response must be concise. 1.07. What is the ratio of the CO2 emissions (% of total fuel combustion) of North America in 2006 to that in 2007?
Give a very brief answer. 0.96. What is the ratio of the CO2 emissions (% of total fuel combustion) of Gabon in 2006 to that in 2007?
Give a very brief answer. 0.96. What is the difference between the highest and the second highest CO2 emissions (% of total fuel combustion) in Latin America(developing only)?
Offer a terse response. 0.48. What is the difference between the highest and the second highest CO2 emissions (% of total fuel combustion) of Lower middle income?
Your answer should be compact. 0.38. What is the difference between the highest and the second highest CO2 emissions (% of total fuel combustion) of North America?
Provide a succinct answer. 0.26. What is the difference between the highest and the second highest CO2 emissions (% of total fuel combustion) in Gabon?
Your answer should be very brief. 0.81. What is the difference between the highest and the lowest CO2 emissions (% of total fuel combustion) of Latin America(developing only)?
Your response must be concise. 1.28. What is the difference between the highest and the lowest CO2 emissions (% of total fuel combustion) of Lower middle income?
Offer a terse response. 1.97. What is the difference between the highest and the lowest CO2 emissions (% of total fuel combustion) in North America?
Your answer should be compact. 1.59. What is the difference between the highest and the lowest CO2 emissions (% of total fuel combustion) of Gabon?
Ensure brevity in your answer.  2.87. 